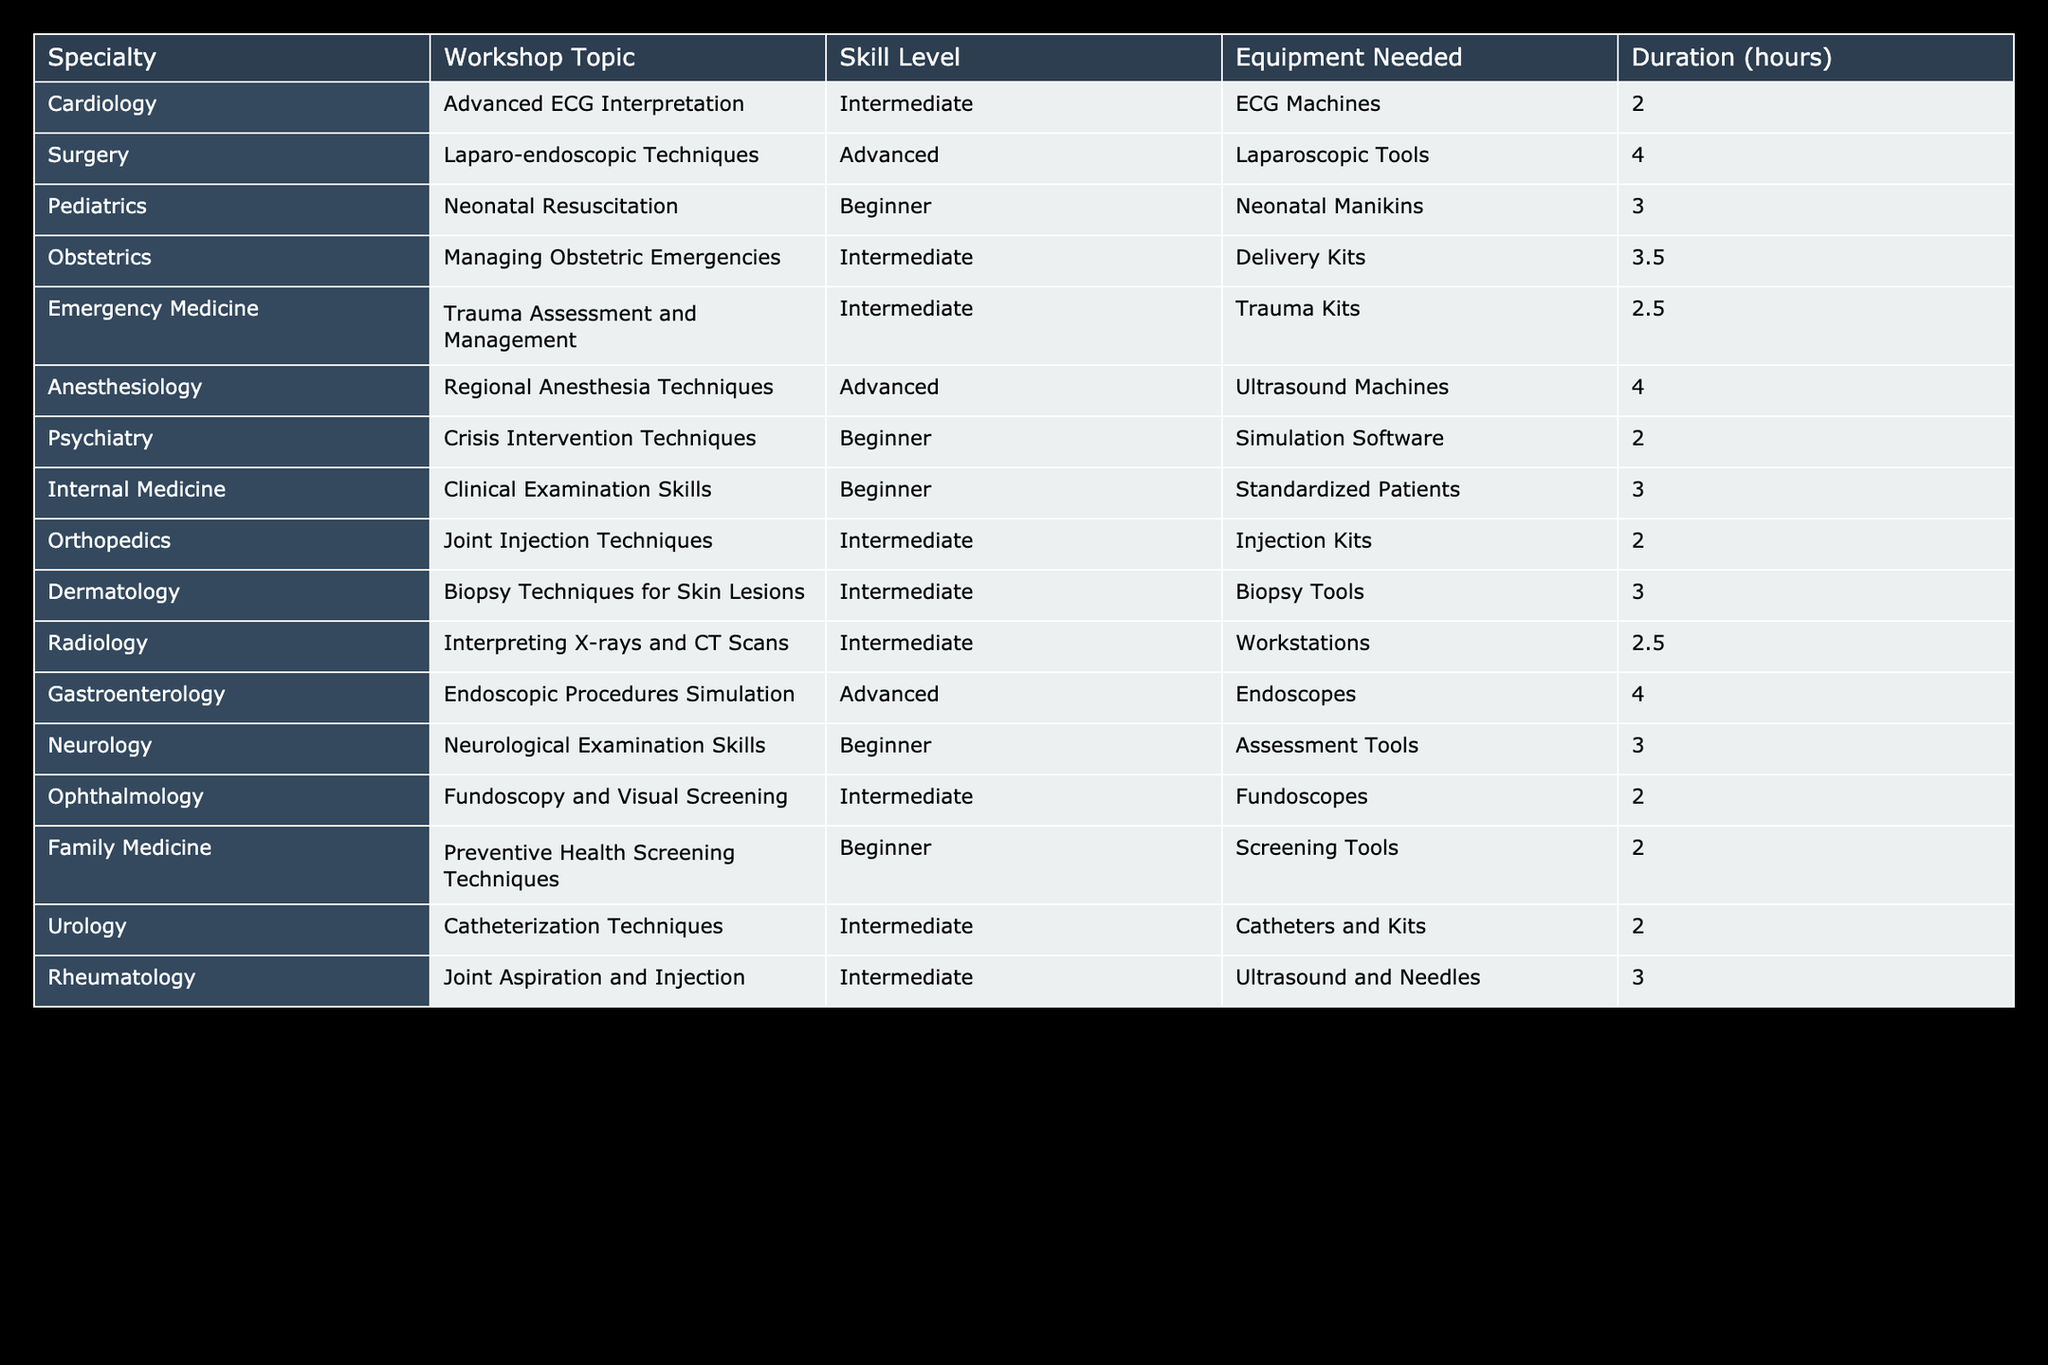What is the duration for the "Neonatal Resuscitation" workshop? The "Neonatal Resuscitation" workshop is listed under Pediatrics. Looking at the table, the duration noted for this workshop is 3 hours.
Answer: 3 hours Which specialty has the longest workshop duration? By examining the duration column for each specialty, we find that "Gastroenterology" has a workshop titled "Endoscopic Procedures Simulation," which is 4 hours long. This is the longest duration in the table.
Answer: Gastroenterology Are there any workshops that require ultrasound machines? In the table, the workshops listed under the Anesthesiology and Gastroenterology specialties both require ultrasound machines. Therefore, the answer is yes.
Answer: Yes How many intermediate-level workshops are there in total? Counting the rows for 'Intermediate' in the Skill Level column: Advanced ECG Interpretation, Managing Obstetric Emergencies, Trauma Assessment and Management, Joint Injection Techniques, Biopsy Techniques for Skin Lesions, Interpreting X-rays and CT Scans, Catheterization Techniques, and Joint Aspiration and Injection, gives us a total of 8 intermediate workshops.
Answer: 8 What is the average duration of workshops that require delivery kits? There is one workshop in the table that requires delivery kits: "Managing Obstetric Emergencies," with a duration of 3.5 hours. Since there's only one workshop, the average duration is 3.5 hours.
Answer: 3.5 hours Do all advanced workshops require more than 3 hours? Looking at the advanced-level workshops—"Laparo-endoscopic Techniques," "Regional Anesthesia Techniques," and "Endoscopic Procedures Simulation"—their durations are 4, 4, and 4 hours, respectively. Therefore, yes, all advanced workshops in this table require more than 3 hours.
Answer: Yes What is the total duration of all beginner workshops? For beginners, we have "Neonatal Resuscitation" (3), "Crisis Intervention Techniques" (2), "Clinical Examination Skills" (3), "Neurological Examination Skills" (3), and "Preventive Health Screening Techniques" (2). Therefore, we sum these durations: 3 + 2 + 3 + 3 + 2 = 13 hours.
Answer: 13 hours Which specialty offers a workshop on trauma assessment? By scanning through the table, the specialty offering a workshop on trauma assessment is Emergency Medicine, with a workshop titled "Trauma Assessment and Management."
Answer: Emergency Medicine 